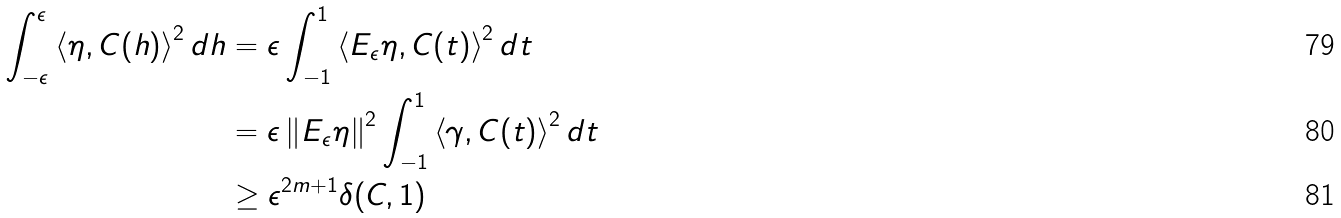Convert formula to latex. <formula><loc_0><loc_0><loc_500><loc_500>\int _ { - \epsilon } ^ { \epsilon } \left < \eta , C ( h ) \right > ^ { 2 } d h & = \epsilon \int _ { - 1 } ^ { 1 } \left < E _ { \epsilon } \eta , C ( t ) \right > ^ { 2 } d t \\ & = \epsilon \left \| E _ { \epsilon } \eta \right \| ^ { 2 } \int _ { - 1 } ^ { 1 } \left < \gamma , C ( t ) \right > ^ { 2 } d t \\ & \geq \epsilon ^ { 2 m + 1 } \delta ( C , 1 )</formula> 